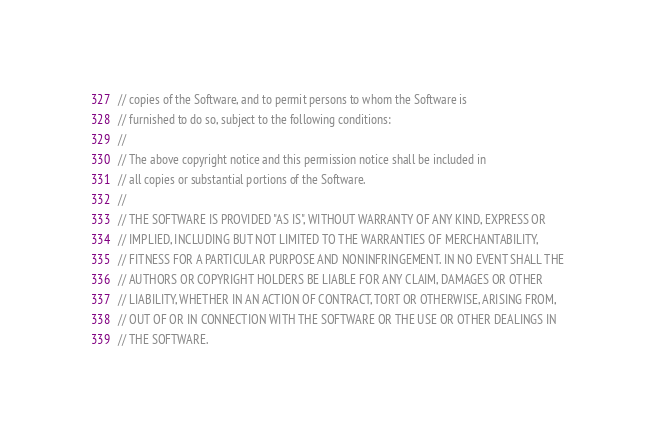Convert code to text. <code><loc_0><loc_0><loc_500><loc_500><_C#_>// copies of the Software, and to permit persons to whom the Software is
// furnished to do so, subject to the following conditions:
//
// The above copyright notice and this permission notice shall be included in
// all copies or substantial portions of the Software.
//
// THE SOFTWARE IS PROVIDED "AS IS", WITHOUT WARRANTY OF ANY KIND, EXPRESS OR
// IMPLIED, INCLUDING BUT NOT LIMITED TO THE WARRANTIES OF MERCHANTABILITY,
// FITNESS FOR A PARTICULAR PURPOSE AND NONINFRINGEMENT. IN NO EVENT SHALL THE
// AUTHORS OR COPYRIGHT HOLDERS BE LIABLE FOR ANY CLAIM, DAMAGES OR OTHER
// LIABILITY, WHETHER IN AN ACTION OF CONTRACT, TORT OR OTHERWISE, ARISING FROM,
// OUT OF OR IN CONNECTION WITH THE SOFTWARE OR THE USE OR OTHER DEALINGS IN
// THE SOFTWARE.
</code> 